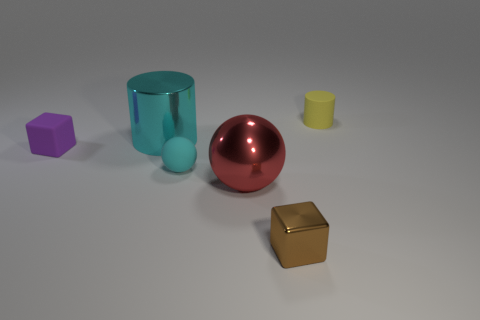Is the number of small cyan spheres right of the yellow matte cylinder the same as the number of cubes that are left of the cyan rubber sphere?
Ensure brevity in your answer.  No. Are the cube that is behind the brown cube and the object that is behind the large cyan shiny object made of the same material?
Make the answer very short. Yes. What number of other things are the same size as the shiny ball?
Provide a short and direct response. 1. How many things are either red cubes or tiny objects that are to the left of the tiny matte cylinder?
Offer a very short reply. 3. Are there the same number of cyan metallic cylinders to the right of the large cyan shiny thing and small cylinders?
Offer a very short reply. No. What is the shape of the brown object that is the same material as the large ball?
Offer a very short reply. Cube. Is there a tiny cylinder of the same color as the shiny block?
Provide a short and direct response. No. What number of matte things are small brown things or blocks?
Your answer should be compact. 1. There is a metallic thing that is in front of the red sphere; what number of purple rubber blocks are in front of it?
Provide a short and direct response. 0. How many large balls have the same material as the large red thing?
Your response must be concise. 0. 